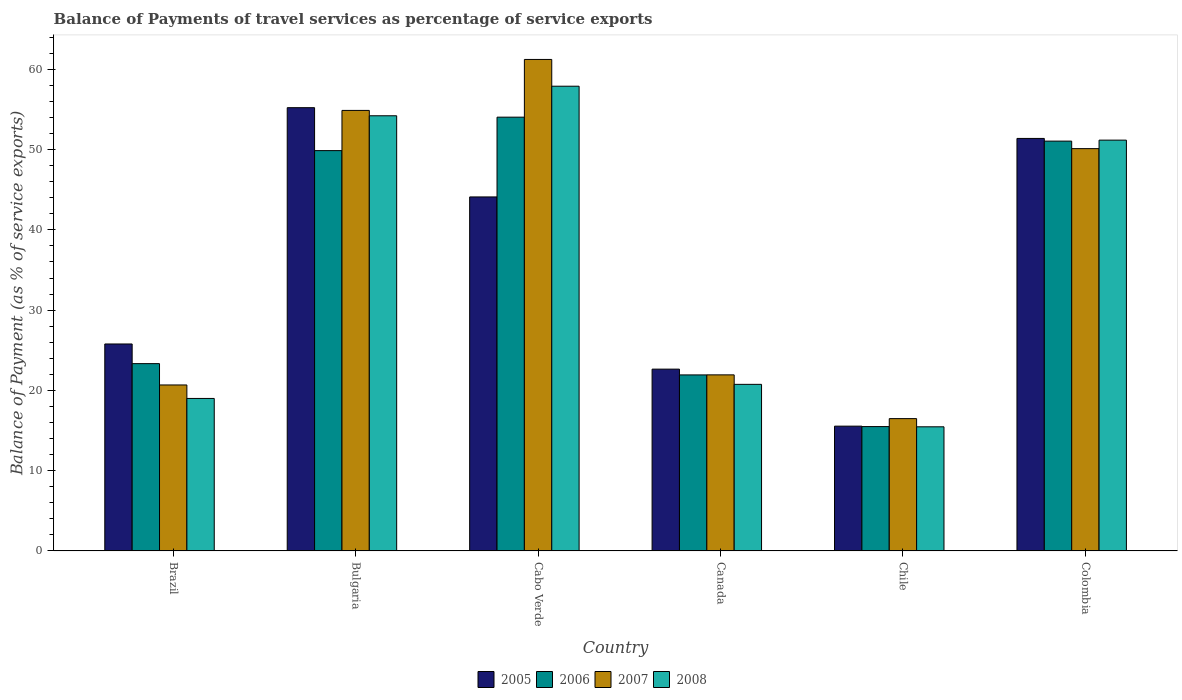Are the number of bars per tick equal to the number of legend labels?
Give a very brief answer. Yes. How many bars are there on the 6th tick from the right?
Your answer should be compact. 4. What is the label of the 5th group of bars from the left?
Make the answer very short. Chile. What is the balance of payments of travel services in 2006 in Canada?
Offer a terse response. 21.93. Across all countries, what is the maximum balance of payments of travel services in 2008?
Keep it short and to the point. 57.9. Across all countries, what is the minimum balance of payments of travel services in 2005?
Provide a succinct answer. 15.55. In which country was the balance of payments of travel services in 2005 maximum?
Offer a terse response. Bulgaria. In which country was the balance of payments of travel services in 2007 minimum?
Offer a terse response. Chile. What is the total balance of payments of travel services in 2005 in the graph?
Your answer should be compact. 214.7. What is the difference between the balance of payments of travel services in 2007 in Bulgaria and that in Cabo Verde?
Ensure brevity in your answer.  -6.35. What is the difference between the balance of payments of travel services in 2006 in Canada and the balance of payments of travel services in 2008 in Brazil?
Offer a very short reply. 2.93. What is the average balance of payments of travel services in 2008 per country?
Offer a terse response. 36.42. What is the difference between the balance of payments of travel services of/in 2008 and balance of payments of travel services of/in 2007 in Colombia?
Provide a short and direct response. 1.06. In how many countries, is the balance of payments of travel services in 2007 greater than 56 %?
Your answer should be very brief. 1. What is the ratio of the balance of payments of travel services in 2008 in Brazil to that in Chile?
Provide a short and direct response. 1.23. Is the difference between the balance of payments of travel services in 2008 in Canada and Colombia greater than the difference between the balance of payments of travel services in 2007 in Canada and Colombia?
Make the answer very short. No. What is the difference between the highest and the second highest balance of payments of travel services in 2008?
Provide a short and direct response. 6.72. What is the difference between the highest and the lowest balance of payments of travel services in 2005?
Provide a succinct answer. 39.68. What does the 4th bar from the right in Cabo Verde represents?
Make the answer very short. 2005. Are all the bars in the graph horizontal?
Provide a succinct answer. No. Does the graph contain grids?
Your answer should be compact. No. Where does the legend appear in the graph?
Give a very brief answer. Bottom center. How many legend labels are there?
Offer a very short reply. 4. How are the legend labels stacked?
Make the answer very short. Horizontal. What is the title of the graph?
Keep it short and to the point. Balance of Payments of travel services as percentage of service exports. What is the label or title of the Y-axis?
Provide a short and direct response. Balance of Payment (as % of service exports). What is the Balance of Payment (as % of service exports) in 2005 in Brazil?
Keep it short and to the point. 25.78. What is the Balance of Payment (as % of service exports) of 2006 in Brazil?
Give a very brief answer. 23.34. What is the Balance of Payment (as % of service exports) in 2007 in Brazil?
Provide a succinct answer. 20.68. What is the Balance of Payment (as % of service exports) of 2008 in Brazil?
Your response must be concise. 19. What is the Balance of Payment (as % of service exports) in 2005 in Bulgaria?
Offer a very short reply. 55.22. What is the Balance of Payment (as % of service exports) of 2006 in Bulgaria?
Provide a succinct answer. 49.87. What is the Balance of Payment (as % of service exports) of 2007 in Bulgaria?
Make the answer very short. 54.88. What is the Balance of Payment (as % of service exports) of 2008 in Bulgaria?
Your answer should be compact. 54.22. What is the Balance of Payment (as % of service exports) in 2005 in Cabo Verde?
Your answer should be very brief. 44.1. What is the Balance of Payment (as % of service exports) in 2006 in Cabo Verde?
Make the answer very short. 54.04. What is the Balance of Payment (as % of service exports) in 2007 in Cabo Verde?
Provide a succinct answer. 61.23. What is the Balance of Payment (as % of service exports) in 2008 in Cabo Verde?
Ensure brevity in your answer.  57.9. What is the Balance of Payment (as % of service exports) in 2005 in Canada?
Make the answer very short. 22.65. What is the Balance of Payment (as % of service exports) in 2006 in Canada?
Provide a short and direct response. 21.93. What is the Balance of Payment (as % of service exports) of 2007 in Canada?
Ensure brevity in your answer.  21.94. What is the Balance of Payment (as % of service exports) of 2008 in Canada?
Give a very brief answer. 20.75. What is the Balance of Payment (as % of service exports) of 2005 in Chile?
Give a very brief answer. 15.55. What is the Balance of Payment (as % of service exports) in 2006 in Chile?
Offer a very short reply. 15.49. What is the Balance of Payment (as % of service exports) of 2007 in Chile?
Your answer should be compact. 16.48. What is the Balance of Payment (as % of service exports) of 2008 in Chile?
Ensure brevity in your answer.  15.46. What is the Balance of Payment (as % of service exports) in 2005 in Colombia?
Provide a succinct answer. 51.39. What is the Balance of Payment (as % of service exports) in 2006 in Colombia?
Provide a succinct answer. 51.06. What is the Balance of Payment (as % of service exports) in 2007 in Colombia?
Ensure brevity in your answer.  50.12. What is the Balance of Payment (as % of service exports) in 2008 in Colombia?
Offer a very short reply. 51.18. Across all countries, what is the maximum Balance of Payment (as % of service exports) of 2005?
Your answer should be very brief. 55.22. Across all countries, what is the maximum Balance of Payment (as % of service exports) of 2006?
Your response must be concise. 54.04. Across all countries, what is the maximum Balance of Payment (as % of service exports) in 2007?
Your answer should be compact. 61.23. Across all countries, what is the maximum Balance of Payment (as % of service exports) of 2008?
Your answer should be compact. 57.9. Across all countries, what is the minimum Balance of Payment (as % of service exports) of 2005?
Keep it short and to the point. 15.55. Across all countries, what is the minimum Balance of Payment (as % of service exports) in 2006?
Give a very brief answer. 15.49. Across all countries, what is the minimum Balance of Payment (as % of service exports) of 2007?
Offer a very short reply. 16.48. Across all countries, what is the minimum Balance of Payment (as % of service exports) of 2008?
Offer a very short reply. 15.46. What is the total Balance of Payment (as % of service exports) of 2005 in the graph?
Provide a succinct answer. 214.7. What is the total Balance of Payment (as % of service exports) in 2006 in the graph?
Your response must be concise. 215.73. What is the total Balance of Payment (as % of service exports) of 2007 in the graph?
Provide a succinct answer. 225.33. What is the total Balance of Payment (as % of service exports) of 2008 in the graph?
Provide a succinct answer. 218.51. What is the difference between the Balance of Payment (as % of service exports) in 2005 in Brazil and that in Bulgaria?
Offer a very short reply. -29.44. What is the difference between the Balance of Payment (as % of service exports) in 2006 in Brazil and that in Bulgaria?
Offer a very short reply. -26.54. What is the difference between the Balance of Payment (as % of service exports) of 2007 in Brazil and that in Bulgaria?
Provide a succinct answer. -34.21. What is the difference between the Balance of Payment (as % of service exports) in 2008 in Brazil and that in Bulgaria?
Provide a succinct answer. -35.22. What is the difference between the Balance of Payment (as % of service exports) in 2005 in Brazil and that in Cabo Verde?
Your answer should be very brief. -18.32. What is the difference between the Balance of Payment (as % of service exports) of 2006 in Brazil and that in Cabo Verde?
Provide a short and direct response. -30.71. What is the difference between the Balance of Payment (as % of service exports) of 2007 in Brazil and that in Cabo Verde?
Make the answer very short. -40.56. What is the difference between the Balance of Payment (as % of service exports) of 2008 in Brazil and that in Cabo Verde?
Keep it short and to the point. -38.9. What is the difference between the Balance of Payment (as % of service exports) of 2005 in Brazil and that in Canada?
Provide a succinct answer. 3.14. What is the difference between the Balance of Payment (as % of service exports) in 2006 in Brazil and that in Canada?
Ensure brevity in your answer.  1.41. What is the difference between the Balance of Payment (as % of service exports) of 2007 in Brazil and that in Canada?
Offer a terse response. -1.26. What is the difference between the Balance of Payment (as % of service exports) in 2008 in Brazil and that in Canada?
Your response must be concise. -1.76. What is the difference between the Balance of Payment (as % of service exports) of 2005 in Brazil and that in Chile?
Your answer should be very brief. 10.24. What is the difference between the Balance of Payment (as % of service exports) of 2006 in Brazil and that in Chile?
Your response must be concise. 7.84. What is the difference between the Balance of Payment (as % of service exports) in 2007 in Brazil and that in Chile?
Keep it short and to the point. 4.19. What is the difference between the Balance of Payment (as % of service exports) in 2008 in Brazil and that in Chile?
Make the answer very short. 3.53. What is the difference between the Balance of Payment (as % of service exports) in 2005 in Brazil and that in Colombia?
Keep it short and to the point. -25.61. What is the difference between the Balance of Payment (as % of service exports) in 2006 in Brazil and that in Colombia?
Give a very brief answer. -27.72. What is the difference between the Balance of Payment (as % of service exports) in 2007 in Brazil and that in Colombia?
Ensure brevity in your answer.  -29.44. What is the difference between the Balance of Payment (as % of service exports) in 2008 in Brazil and that in Colombia?
Your answer should be very brief. -32.18. What is the difference between the Balance of Payment (as % of service exports) in 2005 in Bulgaria and that in Cabo Verde?
Provide a succinct answer. 11.12. What is the difference between the Balance of Payment (as % of service exports) of 2006 in Bulgaria and that in Cabo Verde?
Give a very brief answer. -4.17. What is the difference between the Balance of Payment (as % of service exports) of 2007 in Bulgaria and that in Cabo Verde?
Your response must be concise. -6.35. What is the difference between the Balance of Payment (as % of service exports) in 2008 in Bulgaria and that in Cabo Verde?
Provide a succinct answer. -3.68. What is the difference between the Balance of Payment (as % of service exports) in 2005 in Bulgaria and that in Canada?
Provide a succinct answer. 32.57. What is the difference between the Balance of Payment (as % of service exports) of 2006 in Bulgaria and that in Canada?
Offer a very short reply. 27.94. What is the difference between the Balance of Payment (as % of service exports) in 2007 in Bulgaria and that in Canada?
Provide a succinct answer. 32.95. What is the difference between the Balance of Payment (as % of service exports) in 2008 in Bulgaria and that in Canada?
Provide a short and direct response. 33.46. What is the difference between the Balance of Payment (as % of service exports) in 2005 in Bulgaria and that in Chile?
Keep it short and to the point. 39.68. What is the difference between the Balance of Payment (as % of service exports) in 2006 in Bulgaria and that in Chile?
Your answer should be compact. 34.38. What is the difference between the Balance of Payment (as % of service exports) in 2007 in Bulgaria and that in Chile?
Your answer should be compact. 38.4. What is the difference between the Balance of Payment (as % of service exports) of 2008 in Bulgaria and that in Chile?
Your answer should be compact. 38.75. What is the difference between the Balance of Payment (as % of service exports) of 2005 in Bulgaria and that in Colombia?
Your response must be concise. 3.83. What is the difference between the Balance of Payment (as % of service exports) of 2006 in Bulgaria and that in Colombia?
Your answer should be very brief. -1.18. What is the difference between the Balance of Payment (as % of service exports) of 2007 in Bulgaria and that in Colombia?
Make the answer very short. 4.76. What is the difference between the Balance of Payment (as % of service exports) of 2008 in Bulgaria and that in Colombia?
Keep it short and to the point. 3.03. What is the difference between the Balance of Payment (as % of service exports) of 2005 in Cabo Verde and that in Canada?
Provide a succinct answer. 21.45. What is the difference between the Balance of Payment (as % of service exports) of 2006 in Cabo Verde and that in Canada?
Provide a succinct answer. 32.11. What is the difference between the Balance of Payment (as % of service exports) of 2007 in Cabo Verde and that in Canada?
Offer a terse response. 39.3. What is the difference between the Balance of Payment (as % of service exports) in 2008 in Cabo Verde and that in Canada?
Your answer should be very brief. 37.14. What is the difference between the Balance of Payment (as % of service exports) in 2005 in Cabo Verde and that in Chile?
Your response must be concise. 28.56. What is the difference between the Balance of Payment (as % of service exports) of 2006 in Cabo Verde and that in Chile?
Ensure brevity in your answer.  38.55. What is the difference between the Balance of Payment (as % of service exports) of 2007 in Cabo Verde and that in Chile?
Provide a short and direct response. 44.75. What is the difference between the Balance of Payment (as % of service exports) of 2008 in Cabo Verde and that in Chile?
Give a very brief answer. 42.43. What is the difference between the Balance of Payment (as % of service exports) of 2005 in Cabo Verde and that in Colombia?
Your answer should be very brief. -7.29. What is the difference between the Balance of Payment (as % of service exports) of 2006 in Cabo Verde and that in Colombia?
Your response must be concise. 2.98. What is the difference between the Balance of Payment (as % of service exports) in 2007 in Cabo Verde and that in Colombia?
Offer a very short reply. 11.11. What is the difference between the Balance of Payment (as % of service exports) of 2008 in Cabo Verde and that in Colombia?
Provide a short and direct response. 6.72. What is the difference between the Balance of Payment (as % of service exports) in 2005 in Canada and that in Chile?
Provide a short and direct response. 7.1. What is the difference between the Balance of Payment (as % of service exports) in 2006 in Canada and that in Chile?
Offer a terse response. 6.44. What is the difference between the Balance of Payment (as % of service exports) of 2007 in Canada and that in Chile?
Your response must be concise. 5.45. What is the difference between the Balance of Payment (as % of service exports) of 2008 in Canada and that in Chile?
Keep it short and to the point. 5.29. What is the difference between the Balance of Payment (as % of service exports) of 2005 in Canada and that in Colombia?
Provide a short and direct response. -28.74. What is the difference between the Balance of Payment (as % of service exports) of 2006 in Canada and that in Colombia?
Provide a short and direct response. -29.13. What is the difference between the Balance of Payment (as % of service exports) in 2007 in Canada and that in Colombia?
Your answer should be very brief. -28.19. What is the difference between the Balance of Payment (as % of service exports) in 2008 in Canada and that in Colombia?
Your response must be concise. -30.43. What is the difference between the Balance of Payment (as % of service exports) of 2005 in Chile and that in Colombia?
Your response must be concise. -35.85. What is the difference between the Balance of Payment (as % of service exports) of 2006 in Chile and that in Colombia?
Ensure brevity in your answer.  -35.57. What is the difference between the Balance of Payment (as % of service exports) of 2007 in Chile and that in Colombia?
Provide a succinct answer. -33.64. What is the difference between the Balance of Payment (as % of service exports) in 2008 in Chile and that in Colombia?
Your response must be concise. -35.72. What is the difference between the Balance of Payment (as % of service exports) of 2005 in Brazil and the Balance of Payment (as % of service exports) of 2006 in Bulgaria?
Offer a very short reply. -24.09. What is the difference between the Balance of Payment (as % of service exports) of 2005 in Brazil and the Balance of Payment (as % of service exports) of 2007 in Bulgaria?
Your response must be concise. -29.1. What is the difference between the Balance of Payment (as % of service exports) in 2005 in Brazil and the Balance of Payment (as % of service exports) in 2008 in Bulgaria?
Provide a succinct answer. -28.43. What is the difference between the Balance of Payment (as % of service exports) of 2006 in Brazil and the Balance of Payment (as % of service exports) of 2007 in Bulgaria?
Your answer should be compact. -31.55. What is the difference between the Balance of Payment (as % of service exports) of 2006 in Brazil and the Balance of Payment (as % of service exports) of 2008 in Bulgaria?
Give a very brief answer. -30.88. What is the difference between the Balance of Payment (as % of service exports) of 2007 in Brazil and the Balance of Payment (as % of service exports) of 2008 in Bulgaria?
Offer a terse response. -33.54. What is the difference between the Balance of Payment (as % of service exports) of 2005 in Brazil and the Balance of Payment (as % of service exports) of 2006 in Cabo Verde?
Provide a short and direct response. -28.26. What is the difference between the Balance of Payment (as % of service exports) of 2005 in Brazil and the Balance of Payment (as % of service exports) of 2007 in Cabo Verde?
Provide a short and direct response. -35.45. What is the difference between the Balance of Payment (as % of service exports) of 2005 in Brazil and the Balance of Payment (as % of service exports) of 2008 in Cabo Verde?
Keep it short and to the point. -32.11. What is the difference between the Balance of Payment (as % of service exports) of 2006 in Brazil and the Balance of Payment (as % of service exports) of 2007 in Cabo Verde?
Offer a very short reply. -37.9. What is the difference between the Balance of Payment (as % of service exports) in 2006 in Brazil and the Balance of Payment (as % of service exports) in 2008 in Cabo Verde?
Make the answer very short. -34.56. What is the difference between the Balance of Payment (as % of service exports) in 2007 in Brazil and the Balance of Payment (as % of service exports) in 2008 in Cabo Verde?
Offer a very short reply. -37.22. What is the difference between the Balance of Payment (as % of service exports) in 2005 in Brazil and the Balance of Payment (as % of service exports) in 2006 in Canada?
Your response must be concise. 3.85. What is the difference between the Balance of Payment (as % of service exports) in 2005 in Brazil and the Balance of Payment (as % of service exports) in 2007 in Canada?
Make the answer very short. 3.85. What is the difference between the Balance of Payment (as % of service exports) of 2005 in Brazil and the Balance of Payment (as % of service exports) of 2008 in Canada?
Ensure brevity in your answer.  5.03. What is the difference between the Balance of Payment (as % of service exports) of 2006 in Brazil and the Balance of Payment (as % of service exports) of 2007 in Canada?
Offer a very short reply. 1.4. What is the difference between the Balance of Payment (as % of service exports) of 2006 in Brazil and the Balance of Payment (as % of service exports) of 2008 in Canada?
Provide a short and direct response. 2.58. What is the difference between the Balance of Payment (as % of service exports) of 2007 in Brazil and the Balance of Payment (as % of service exports) of 2008 in Canada?
Your answer should be very brief. -0.08. What is the difference between the Balance of Payment (as % of service exports) in 2005 in Brazil and the Balance of Payment (as % of service exports) in 2006 in Chile?
Your answer should be very brief. 10.29. What is the difference between the Balance of Payment (as % of service exports) of 2005 in Brazil and the Balance of Payment (as % of service exports) of 2007 in Chile?
Make the answer very short. 9.3. What is the difference between the Balance of Payment (as % of service exports) of 2005 in Brazil and the Balance of Payment (as % of service exports) of 2008 in Chile?
Give a very brief answer. 10.32. What is the difference between the Balance of Payment (as % of service exports) in 2006 in Brazil and the Balance of Payment (as % of service exports) in 2007 in Chile?
Keep it short and to the point. 6.85. What is the difference between the Balance of Payment (as % of service exports) of 2006 in Brazil and the Balance of Payment (as % of service exports) of 2008 in Chile?
Your answer should be very brief. 7.87. What is the difference between the Balance of Payment (as % of service exports) in 2007 in Brazil and the Balance of Payment (as % of service exports) in 2008 in Chile?
Keep it short and to the point. 5.21. What is the difference between the Balance of Payment (as % of service exports) in 2005 in Brazil and the Balance of Payment (as % of service exports) in 2006 in Colombia?
Offer a terse response. -25.27. What is the difference between the Balance of Payment (as % of service exports) of 2005 in Brazil and the Balance of Payment (as % of service exports) of 2007 in Colombia?
Ensure brevity in your answer.  -24.34. What is the difference between the Balance of Payment (as % of service exports) of 2005 in Brazil and the Balance of Payment (as % of service exports) of 2008 in Colombia?
Offer a very short reply. -25.4. What is the difference between the Balance of Payment (as % of service exports) of 2006 in Brazil and the Balance of Payment (as % of service exports) of 2007 in Colombia?
Make the answer very short. -26.79. What is the difference between the Balance of Payment (as % of service exports) in 2006 in Brazil and the Balance of Payment (as % of service exports) in 2008 in Colombia?
Give a very brief answer. -27.85. What is the difference between the Balance of Payment (as % of service exports) of 2007 in Brazil and the Balance of Payment (as % of service exports) of 2008 in Colombia?
Make the answer very short. -30.5. What is the difference between the Balance of Payment (as % of service exports) of 2005 in Bulgaria and the Balance of Payment (as % of service exports) of 2006 in Cabo Verde?
Offer a very short reply. 1.18. What is the difference between the Balance of Payment (as % of service exports) in 2005 in Bulgaria and the Balance of Payment (as % of service exports) in 2007 in Cabo Verde?
Keep it short and to the point. -6.01. What is the difference between the Balance of Payment (as % of service exports) of 2005 in Bulgaria and the Balance of Payment (as % of service exports) of 2008 in Cabo Verde?
Provide a succinct answer. -2.67. What is the difference between the Balance of Payment (as % of service exports) of 2006 in Bulgaria and the Balance of Payment (as % of service exports) of 2007 in Cabo Verde?
Provide a succinct answer. -11.36. What is the difference between the Balance of Payment (as % of service exports) in 2006 in Bulgaria and the Balance of Payment (as % of service exports) in 2008 in Cabo Verde?
Your answer should be compact. -8.02. What is the difference between the Balance of Payment (as % of service exports) of 2007 in Bulgaria and the Balance of Payment (as % of service exports) of 2008 in Cabo Verde?
Your answer should be very brief. -3.02. What is the difference between the Balance of Payment (as % of service exports) in 2005 in Bulgaria and the Balance of Payment (as % of service exports) in 2006 in Canada?
Give a very brief answer. 33.29. What is the difference between the Balance of Payment (as % of service exports) of 2005 in Bulgaria and the Balance of Payment (as % of service exports) of 2007 in Canada?
Give a very brief answer. 33.29. What is the difference between the Balance of Payment (as % of service exports) in 2005 in Bulgaria and the Balance of Payment (as % of service exports) in 2008 in Canada?
Offer a very short reply. 34.47. What is the difference between the Balance of Payment (as % of service exports) of 2006 in Bulgaria and the Balance of Payment (as % of service exports) of 2007 in Canada?
Provide a succinct answer. 27.94. What is the difference between the Balance of Payment (as % of service exports) of 2006 in Bulgaria and the Balance of Payment (as % of service exports) of 2008 in Canada?
Provide a short and direct response. 29.12. What is the difference between the Balance of Payment (as % of service exports) in 2007 in Bulgaria and the Balance of Payment (as % of service exports) in 2008 in Canada?
Make the answer very short. 34.13. What is the difference between the Balance of Payment (as % of service exports) of 2005 in Bulgaria and the Balance of Payment (as % of service exports) of 2006 in Chile?
Your answer should be very brief. 39.73. What is the difference between the Balance of Payment (as % of service exports) in 2005 in Bulgaria and the Balance of Payment (as % of service exports) in 2007 in Chile?
Your response must be concise. 38.74. What is the difference between the Balance of Payment (as % of service exports) of 2005 in Bulgaria and the Balance of Payment (as % of service exports) of 2008 in Chile?
Provide a succinct answer. 39.76. What is the difference between the Balance of Payment (as % of service exports) in 2006 in Bulgaria and the Balance of Payment (as % of service exports) in 2007 in Chile?
Ensure brevity in your answer.  33.39. What is the difference between the Balance of Payment (as % of service exports) in 2006 in Bulgaria and the Balance of Payment (as % of service exports) in 2008 in Chile?
Offer a terse response. 34.41. What is the difference between the Balance of Payment (as % of service exports) in 2007 in Bulgaria and the Balance of Payment (as % of service exports) in 2008 in Chile?
Ensure brevity in your answer.  39.42. What is the difference between the Balance of Payment (as % of service exports) in 2005 in Bulgaria and the Balance of Payment (as % of service exports) in 2006 in Colombia?
Ensure brevity in your answer.  4.17. What is the difference between the Balance of Payment (as % of service exports) in 2005 in Bulgaria and the Balance of Payment (as % of service exports) in 2007 in Colombia?
Keep it short and to the point. 5.1. What is the difference between the Balance of Payment (as % of service exports) of 2005 in Bulgaria and the Balance of Payment (as % of service exports) of 2008 in Colombia?
Your answer should be compact. 4.04. What is the difference between the Balance of Payment (as % of service exports) of 2006 in Bulgaria and the Balance of Payment (as % of service exports) of 2007 in Colombia?
Make the answer very short. -0.25. What is the difference between the Balance of Payment (as % of service exports) in 2006 in Bulgaria and the Balance of Payment (as % of service exports) in 2008 in Colombia?
Provide a succinct answer. -1.31. What is the difference between the Balance of Payment (as % of service exports) in 2007 in Bulgaria and the Balance of Payment (as % of service exports) in 2008 in Colombia?
Offer a terse response. 3.7. What is the difference between the Balance of Payment (as % of service exports) of 2005 in Cabo Verde and the Balance of Payment (as % of service exports) of 2006 in Canada?
Offer a very short reply. 22.17. What is the difference between the Balance of Payment (as % of service exports) in 2005 in Cabo Verde and the Balance of Payment (as % of service exports) in 2007 in Canada?
Offer a terse response. 22.17. What is the difference between the Balance of Payment (as % of service exports) of 2005 in Cabo Verde and the Balance of Payment (as % of service exports) of 2008 in Canada?
Give a very brief answer. 23.35. What is the difference between the Balance of Payment (as % of service exports) in 2006 in Cabo Verde and the Balance of Payment (as % of service exports) in 2007 in Canada?
Give a very brief answer. 32.11. What is the difference between the Balance of Payment (as % of service exports) of 2006 in Cabo Verde and the Balance of Payment (as % of service exports) of 2008 in Canada?
Provide a short and direct response. 33.29. What is the difference between the Balance of Payment (as % of service exports) of 2007 in Cabo Verde and the Balance of Payment (as % of service exports) of 2008 in Canada?
Make the answer very short. 40.48. What is the difference between the Balance of Payment (as % of service exports) in 2005 in Cabo Verde and the Balance of Payment (as % of service exports) in 2006 in Chile?
Provide a succinct answer. 28.61. What is the difference between the Balance of Payment (as % of service exports) in 2005 in Cabo Verde and the Balance of Payment (as % of service exports) in 2007 in Chile?
Keep it short and to the point. 27.62. What is the difference between the Balance of Payment (as % of service exports) of 2005 in Cabo Verde and the Balance of Payment (as % of service exports) of 2008 in Chile?
Give a very brief answer. 28.64. What is the difference between the Balance of Payment (as % of service exports) of 2006 in Cabo Verde and the Balance of Payment (as % of service exports) of 2007 in Chile?
Ensure brevity in your answer.  37.56. What is the difference between the Balance of Payment (as % of service exports) in 2006 in Cabo Verde and the Balance of Payment (as % of service exports) in 2008 in Chile?
Provide a succinct answer. 38.58. What is the difference between the Balance of Payment (as % of service exports) in 2007 in Cabo Verde and the Balance of Payment (as % of service exports) in 2008 in Chile?
Ensure brevity in your answer.  45.77. What is the difference between the Balance of Payment (as % of service exports) in 2005 in Cabo Verde and the Balance of Payment (as % of service exports) in 2006 in Colombia?
Offer a very short reply. -6.95. What is the difference between the Balance of Payment (as % of service exports) in 2005 in Cabo Verde and the Balance of Payment (as % of service exports) in 2007 in Colombia?
Make the answer very short. -6.02. What is the difference between the Balance of Payment (as % of service exports) of 2005 in Cabo Verde and the Balance of Payment (as % of service exports) of 2008 in Colombia?
Make the answer very short. -7.08. What is the difference between the Balance of Payment (as % of service exports) in 2006 in Cabo Verde and the Balance of Payment (as % of service exports) in 2007 in Colombia?
Your answer should be very brief. 3.92. What is the difference between the Balance of Payment (as % of service exports) in 2006 in Cabo Verde and the Balance of Payment (as % of service exports) in 2008 in Colombia?
Offer a terse response. 2.86. What is the difference between the Balance of Payment (as % of service exports) of 2007 in Cabo Verde and the Balance of Payment (as % of service exports) of 2008 in Colombia?
Your response must be concise. 10.05. What is the difference between the Balance of Payment (as % of service exports) of 2005 in Canada and the Balance of Payment (as % of service exports) of 2006 in Chile?
Provide a succinct answer. 7.16. What is the difference between the Balance of Payment (as % of service exports) in 2005 in Canada and the Balance of Payment (as % of service exports) in 2007 in Chile?
Keep it short and to the point. 6.16. What is the difference between the Balance of Payment (as % of service exports) in 2005 in Canada and the Balance of Payment (as % of service exports) in 2008 in Chile?
Provide a short and direct response. 7.19. What is the difference between the Balance of Payment (as % of service exports) of 2006 in Canada and the Balance of Payment (as % of service exports) of 2007 in Chile?
Your answer should be very brief. 5.45. What is the difference between the Balance of Payment (as % of service exports) in 2006 in Canada and the Balance of Payment (as % of service exports) in 2008 in Chile?
Your answer should be very brief. 6.47. What is the difference between the Balance of Payment (as % of service exports) of 2007 in Canada and the Balance of Payment (as % of service exports) of 2008 in Chile?
Offer a very short reply. 6.47. What is the difference between the Balance of Payment (as % of service exports) of 2005 in Canada and the Balance of Payment (as % of service exports) of 2006 in Colombia?
Provide a succinct answer. -28.41. What is the difference between the Balance of Payment (as % of service exports) of 2005 in Canada and the Balance of Payment (as % of service exports) of 2007 in Colombia?
Give a very brief answer. -27.47. What is the difference between the Balance of Payment (as % of service exports) of 2005 in Canada and the Balance of Payment (as % of service exports) of 2008 in Colombia?
Give a very brief answer. -28.53. What is the difference between the Balance of Payment (as % of service exports) in 2006 in Canada and the Balance of Payment (as % of service exports) in 2007 in Colombia?
Make the answer very short. -28.19. What is the difference between the Balance of Payment (as % of service exports) in 2006 in Canada and the Balance of Payment (as % of service exports) in 2008 in Colombia?
Keep it short and to the point. -29.25. What is the difference between the Balance of Payment (as % of service exports) in 2007 in Canada and the Balance of Payment (as % of service exports) in 2008 in Colombia?
Provide a succinct answer. -29.25. What is the difference between the Balance of Payment (as % of service exports) in 2005 in Chile and the Balance of Payment (as % of service exports) in 2006 in Colombia?
Provide a short and direct response. -35.51. What is the difference between the Balance of Payment (as % of service exports) in 2005 in Chile and the Balance of Payment (as % of service exports) in 2007 in Colombia?
Offer a terse response. -34.58. What is the difference between the Balance of Payment (as % of service exports) in 2005 in Chile and the Balance of Payment (as % of service exports) in 2008 in Colombia?
Make the answer very short. -35.64. What is the difference between the Balance of Payment (as % of service exports) of 2006 in Chile and the Balance of Payment (as % of service exports) of 2007 in Colombia?
Keep it short and to the point. -34.63. What is the difference between the Balance of Payment (as % of service exports) in 2006 in Chile and the Balance of Payment (as % of service exports) in 2008 in Colombia?
Offer a very short reply. -35.69. What is the difference between the Balance of Payment (as % of service exports) of 2007 in Chile and the Balance of Payment (as % of service exports) of 2008 in Colombia?
Offer a terse response. -34.7. What is the average Balance of Payment (as % of service exports) of 2005 per country?
Make the answer very short. 35.78. What is the average Balance of Payment (as % of service exports) in 2006 per country?
Your response must be concise. 35.95. What is the average Balance of Payment (as % of service exports) of 2007 per country?
Your response must be concise. 37.56. What is the average Balance of Payment (as % of service exports) in 2008 per country?
Provide a succinct answer. 36.42. What is the difference between the Balance of Payment (as % of service exports) in 2005 and Balance of Payment (as % of service exports) in 2006 in Brazil?
Give a very brief answer. 2.45. What is the difference between the Balance of Payment (as % of service exports) in 2005 and Balance of Payment (as % of service exports) in 2007 in Brazil?
Offer a terse response. 5.11. What is the difference between the Balance of Payment (as % of service exports) in 2005 and Balance of Payment (as % of service exports) in 2008 in Brazil?
Your answer should be compact. 6.79. What is the difference between the Balance of Payment (as % of service exports) in 2006 and Balance of Payment (as % of service exports) in 2007 in Brazil?
Ensure brevity in your answer.  2.66. What is the difference between the Balance of Payment (as % of service exports) in 2006 and Balance of Payment (as % of service exports) in 2008 in Brazil?
Provide a short and direct response. 4.34. What is the difference between the Balance of Payment (as % of service exports) of 2007 and Balance of Payment (as % of service exports) of 2008 in Brazil?
Make the answer very short. 1.68. What is the difference between the Balance of Payment (as % of service exports) in 2005 and Balance of Payment (as % of service exports) in 2006 in Bulgaria?
Provide a short and direct response. 5.35. What is the difference between the Balance of Payment (as % of service exports) of 2005 and Balance of Payment (as % of service exports) of 2007 in Bulgaria?
Provide a short and direct response. 0.34. What is the difference between the Balance of Payment (as % of service exports) of 2005 and Balance of Payment (as % of service exports) of 2008 in Bulgaria?
Provide a succinct answer. 1.01. What is the difference between the Balance of Payment (as % of service exports) in 2006 and Balance of Payment (as % of service exports) in 2007 in Bulgaria?
Your response must be concise. -5.01. What is the difference between the Balance of Payment (as % of service exports) of 2006 and Balance of Payment (as % of service exports) of 2008 in Bulgaria?
Provide a short and direct response. -4.34. What is the difference between the Balance of Payment (as % of service exports) of 2007 and Balance of Payment (as % of service exports) of 2008 in Bulgaria?
Provide a short and direct response. 0.67. What is the difference between the Balance of Payment (as % of service exports) of 2005 and Balance of Payment (as % of service exports) of 2006 in Cabo Verde?
Provide a short and direct response. -9.94. What is the difference between the Balance of Payment (as % of service exports) of 2005 and Balance of Payment (as % of service exports) of 2007 in Cabo Verde?
Make the answer very short. -17.13. What is the difference between the Balance of Payment (as % of service exports) of 2005 and Balance of Payment (as % of service exports) of 2008 in Cabo Verde?
Your answer should be very brief. -13.79. What is the difference between the Balance of Payment (as % of service exports) of 2006 and Balance of Payment (as % of service exports) of 2007 in Cabo Verde?
Provide a short and direct response. -7.19. What is the difference between the Balance of Payment (as % of service exports) in 2006 and Balance of Payment (as % of service exports) in 2008 in Cabo Verde?
Provide a short and direct response. -3.86. What is the difference between the Balance of Payment (as % of service exports) in 2007 and Balance of Payment (as % of service exports) in 2008 in Cabo Verde?
Give a very brief answer. 3.33. What is the difference between the Balance of Payment (as % of service exports) of 2005 and Balance of Payment (as % of service exports) of 2006 in Canada?
Keep it short and to the point. 0.72. What is the difference between the Balance of Payment (as % of service exports) of 2005 and Balance of Payment (as % of service exports) of 2007 in Canada?
Ensure brevity in your answer.  0.71. What is the difference between the Balance of Payment (as % of service exports) in 2005 and Balance of Payment (as % of service exports) in 2008 in Canada?
Provide a short and direct response. 1.9. What is the difference between the Balance of Payment (as % of service exports) in 2006 and Balance of Payment (as % of service exports) in 2007 in Canada?
Your answer should be very brief. -0.01. What is the difference between the Balance of Payment (as % of service exports) of 2006 and Balance of Payment (as % of service exports) of 2008 in Canada?
Keep it short and to the point. 1.18. What is the difference between the Balance of Payment (as % of service exports) in 2007 and Balance of Payment (as % of service exports) in 2008 in Canada?
Give a very brief answer. 1.18. What is the difference between the Balance of Payment (as % of service exports) of 2005 and Balance of Payment (as % of service exports) of 2006 in Chile?
Give a very brief answer. 0.05. What is the difference between the Balance of Payment (as % of service exports) of 2005 and Balance of Payment (as % of service exports) of 2007 in Chile?
Offer a very short reply. -0.94. What is the difference between the Balance of Payment (as % of service exports) of 2005 and Balance of Payment (as % of service exports) of 2008 in Chile?
Make the answer very short. 0.08. What is the difference between the Balance of Payment (as % of service exports) of 2006 and Balance of Payment (as % of service exports) of 2007 in Chile?
Your answer should be compact. -0.99. What is the difference between the Balance of Payment (as % of service exports) in 2006 and Balance of Payment (as % of service exports) in 2008 in Chile?
Your answer should be very brief. 0.03. What is the difference between the Balance of Payment (as % of service exports) in 2007 and Balance of Payment (as % of service exports) in 2008 in Chile?
Your response must be concise. 1.02. What is the difference between the Balance of Payment (as % of service exports) of 2005 and Balance of Payment (as % of service exports) of 2006 in Colombia?
Ensure brevity in your answer.  0.33. What is the difference between the Balance of Payment (as % of service exports) in 2005 and Balance of Payment (as % of service exports) in 2007 in Colombia?
Give a very brief answer. 1.27. What is the difference between the Balance of Payment (as % of service exports) in 2005 and Balance of Payment (as % of service exports) in 2008 in Colombia?
Your answer should be very brief. 0.21. What is the difference between the Balance of Payment (as % of service exports) in 2006 and Balance of Payment (as % of service exports) in 2007 in Colombia?
Ensure brevity in your answer.  0.94. What is the difference between the Balance of Payment (as % of service exports) in 2006 and Balance of Payment (as % of service exports) in 2008 in Colombia?
Give a very brief answer. -0.12. What is the difference between the Balance of Payment (as % of service exports) in 2007 and Balance of Payment (as % of service exports) in 2008 in Colombia?
Offer a terse response. -1.06. What is the ratio of the Balance of Payment (as % of service exports) in 2005 in Brazil to that in Bulgaria?
Your answer should be very brief. 0.47. What is the ratio of the Balance of Payment (as % of service exports) of 2006 in Brazil to that in Bulgaria?
Your answer should be very brief. 0.47. What is the ratio of the Balance of Payment (as % of service exports) in 2007 in Brazil to that in Bulgaria?
Keep it short and to the point. 0.38. What is the ratio of the Balance of Payment (as % of service exports) in 2008 in Brazil to that in Bulgaria?
Provide a succinct answer. 0.35. What is the ratio of the Balance of Payment (as % of service exports) of 2005 in Brazil to that in Cabo Verde?
Provide a short and direct response. 0.58. What is the ratio of the Balance of Payment (as % of service exports) in 2006 in Brazil to that in Cabo Verde?
Your answer should be very brief. 0.43. What is the ratio of the Balance of Payment (as % of service exports) in 2007 in Brazil to that in Cabo Verde?
Ensure brevity in your answer.  0.34. What is the ratio of the Balance of Payment (as % of service exports) of 2008 in Brazil to that in Cabo Verde?
Offer a very short reply. 0.33. What is the ratio of the Balance of Payment (as % of service exports) of 2005 in Brazil to that in Canada?
Your answer should be compact. 1.14. What is the ratio of the Balance of Payment (as % of service exports) in 2006 in Brazil to that in Canada?
Offer a very short reply. 1.06. What is the ratio of the Balance of Payment (as % of service exports) in 2007 in Brazil to that in Canada?
Give a very brief answer. 0.94. What is the ratio of the Balance of Payment (as % of service exports) of 2008 in Brazil to that in Canada?
Your response must be concise. 0.92. What is the ratio of the Balance of Payment (as % of service exports) in 2005 in Brazil to that in Chile?
Offer a very short reply. 1.66. What is the ratio of the Balance of Payment (as % of service exports) in 2006 in Brazil to that in Chile?
Provide a succinct answer. 1.51. What is the ratio of the Balance of Payment (as % of service exports) in 2007 in Brazil to that in Chile?
Provide a succinct answer. 1.25. What is the ratio of the Balance of Payment (as % of service exports) in 2008 in Brazil to that in Chile?
Your answer should be very brief. 1.23. What is the ratio of the Balance of Payment (as % of service exports) in 2005 in Brazil to that in Colombia?
Your response must be concise. 0.5. What is the ratio of the Balance of Payment (as % of service exports) of 2006 in Brazil to that in Colombia?
Make the answer very short. 0.46. What is the ratio of the Balance of Payment (as % of service exports) of 2007 in Brazil to that in Colombia?
Provide a succinct answer. 0.41. What is the ratio of the Balance of Payment (as % of service exports) in 2008 in Brazil to that in Colombia?
Your response must be concise. 0.37. What is the ratio of the Balance of Payment (as % of service exports) of 2005 in Bulgaria to that in Cabo Verde?
Give a very brief answer. 1.25. What is the ratio of the Balance of Payment (as % of service exports) of 2006 in Bulgaria to that in Cabo Verde?
Offer a terse response. 0.92. What is the ratio of the Balance of Payment (as % of service exports) of 2007 in Bulgaria to that in Cabo Verde?
Offer a terse response. 0.9. What is the ratio of the Balance of Payment (as % of service exports) of 2008 in Bulgaria to that in Cabo Verde?
Offer a terse response. 0.94. What is the ratio of the Balance of Payment (as % of service exports) in 2005 in Bulgaria to that in Canada?
Offer a terse response. 2.44. What is the ratio of the Balance of Payment (as % of service exports) of 2006 in Bulgaria to that in Canada?
Your response must be concise. 2.27. What is the ratio of the Balance of Payment (as % of service exports) of 2007 in Bulgaria to that in Canada?
Give a very brief answer. 2.5. What is the ratio of the Balance of Payment (as % of service exports) in 2008 in Bulgaria to that in Canada?
Offer a very short reply. 2.61. What is the ratio of the Balance of Payment (as % of service exports) of 2005 in Bulgaria to that in Chile?
Provide a short and direct response. 3.55. What is the ratio of the Balance of Payment (as % of service exports) of 2006 in Bulgaria to that in Chile?
Offer a very short reply. 3.22. What is the ratio of the Balance of Payment (as % of service exports) in 2007 in Bulgaria to that in Chile?
Your answer should be compact. 3.33. What is the ratio of the Balance of Payment (as % of service exports) of 2008 in Bulgaria to that in Chile?
Offer a terse response. 3.51. What is the ratio of the Balance of Payment (as % of service exports) in 2005 in Bulgaria to that in Colombia?
Your answer should be very brief. 1.07. What is the ratio of the Balance of Payment (as % of service exports) of 2006 in Bulgaria to that in Colombia?
Provide a succinct answer. 0.98. What is the ratio of the Balance of Payment (as % of service exports) in 2007 in Bulgaria to that in Colombia?
Your response must be concise. 1.09. What is the ratio of the Balance of Payment (as % of service exports) of 2008 in Bulgaria to that in Colombia?
Offer a very short reply. 1.06. What is the ratio of the Balance of Payment (as % of service exports) of 2005 in Cabo Verde to that in Canada?
Your answer should be compact. 1.95. What is the ratio of the Balance of Payment (as % of service exports) of 2006 in Cabo Verde to that in Canada?
Offer a very short reply. 2.46. What is the ratio of the Balance of Payment (as % of service exports) in 2007 in Cabo Verde to that in Canada?
Offer a terse response. 2.79. What is the ratio of the Balance of Payment (as % of service exports) of 2008 in Cabo Verde to that in Canada?
Your response must be concise. 2.79. What is the ratio of the Balance of Payment (as % of service exports) in 2005 in Cabo Verde to that in Chile?
Keep it short and to the point. 2.84. What is the ratio of the Balance of Payment (as % of service exports) of 2006 in Cabo Verde to that in Chile?
Your answer should be compact. 3.49. What is the ratio of the Balance of Payment (as % of service exports) of 2007 in Cabo Verde to that in Chile?
Make the answer very short. 3.71. What is the ratio of the Balance of Payment (as % of service exports) of 2008 in Cabo Verde to that in Chile?
Provide a short and direct response. 3.74. What is the ratio of the Balance of Payment (as % of service exports) of 2005 in Cabo Verde to that in Colombia?
Provide a short and direct response. 0.86. What is the ratio of the Balance of Payment (as % of service exports) in 2006 in Cabo Verde to that in Colombia?
Ensure brevity in your answer.  1.06. What is the ratio of the Balance of Payment (as % of service exports) in 2007 in Cabo Verde to that in Colombia?
Make the answer very short. 1.22. What is the ratio of the Balance of Payment (as % of service exports) in 2008 in Cabo Verde to that in Colombia?
Ensure brevity in your answer.  1.13. What is the ratio of the Balance of Payment (as % of service exports) of 2005 in Canada to that in Chile?
Keep it short and to the point. 1.46. What is the ratio of the Balance of Payment (as % of service exports) of 2006 in Canada to that in Chile?
Provide a succinct answer. 1.42. What is the ratio of the Balance of Payment (as % of service exports) in 2007 in Canada to that in Chile?
Your response must be concise. 1.33. What is the ratio of the Balance of Payment (as % of service exports) of 2008 in Canada to that in Chile?
Ensure brevity in your answer.  1.34. What is the ratio of the Balance of Payment (as % of service exports) in 2005 in Canada to that in Colombia?
Ensure brevity in your answer.  0.44. What is the ratio of the Balance of Payment (as % of service exports) in 2006 in Canada to that in Colombia?
Your response must be concise. 0.43. What is the ratio of the Balance of Payment (as % of service exports) in 2007 in Canada to that in Colombia?
Your answer should be compact. 0.44. What is the ratio of the Balance of Payment (as % of service exports) in 2008 in Canada to that in Colombia?
Provide a short and direct response. 0.41. What is the ratio of the Balance of Payment (as % of service exports) in 2005 in Chile to that in Colombia?
Make the answer very short. 0.3. What is the ratio of the Balance of Payment (as % of service exports) of 2006 in Chile to that in Colombia?
Your answer should be compact. 0.3. What is the ratio of the Balance of Payment (as % of service exports) of 2007 in Chile to that in Colombia?
Ensure brevity in your answer.  0.33. What is the ratio of the Balance of Payment (as % of service exports) of 2008 in Chile to that in Colombia?
Offer a very short reply. 0.3. What is the difference between the highest and the second highest Balance of Payment (as % of service exports) of 2005?
Your response must be concise. 3.83. What is the difference between the highest and the second highest Balance of Payment (as % of service exports) in 2006?
Your answer should be very brief. 2.98. What is the difference between the highest and the second highest Balance of Payment (as % of service exports) of 2007?
Your response must be concise. 6.35. What is the difference between the highest and the second highest Balance of Payment (as % of service exports) in 2008?
Ensure brevity in your answer.  3.68. What is the difference between the highest and the lowest Balance of Payment (as % of service exports) in 2005?
Provide a succinct answer. 39.68. What is the difference between the highest and the lowest Balance of Payment (as % of service exports) in 2006?
Your response must be concise. 38.55. What is the difference between the highest and the lowest Balance of Payment (as % of service exports) in 2007?
Keep it short and to the point. 44.75. What is the difference between the highest and the lowest Balance of Payment (as % of service exports) in 2008?
Give a very brief answer. 42.43. 